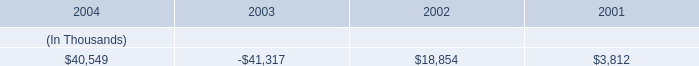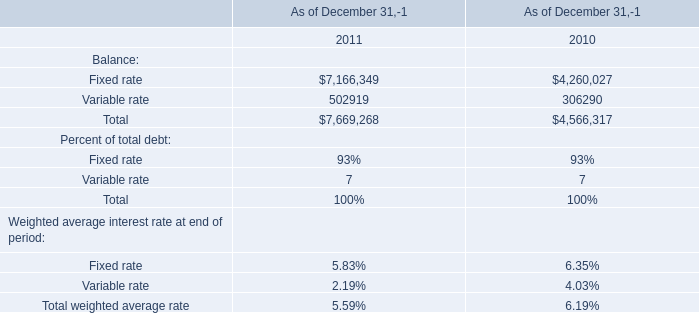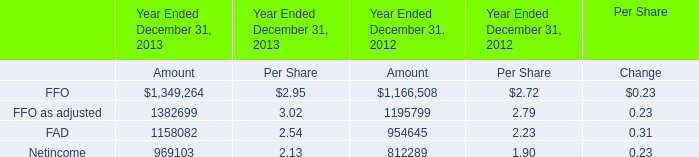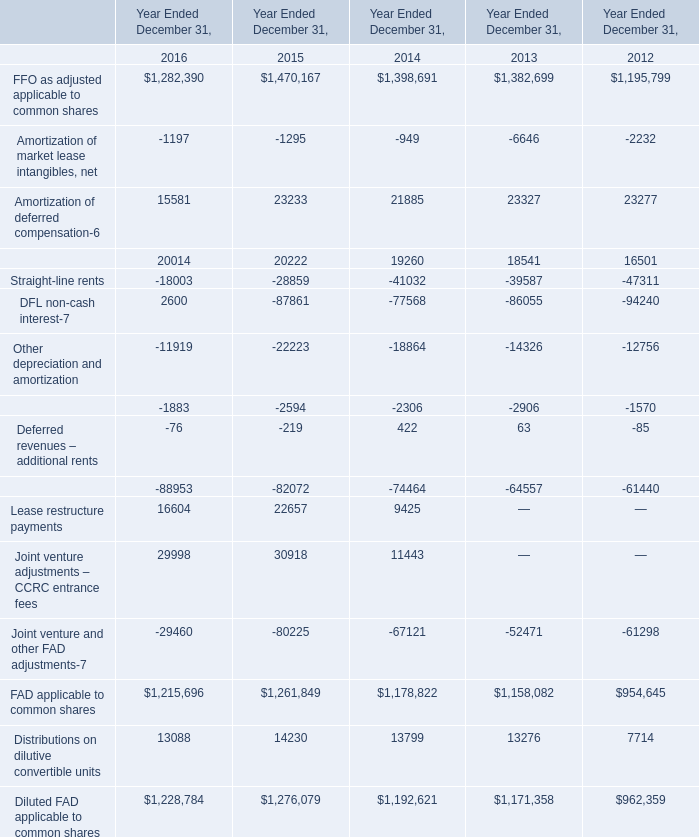Is the total amount of all FFO as adjusted applicable to common shares in 2012 greater than that in 2013 ? 
Answer: no. 